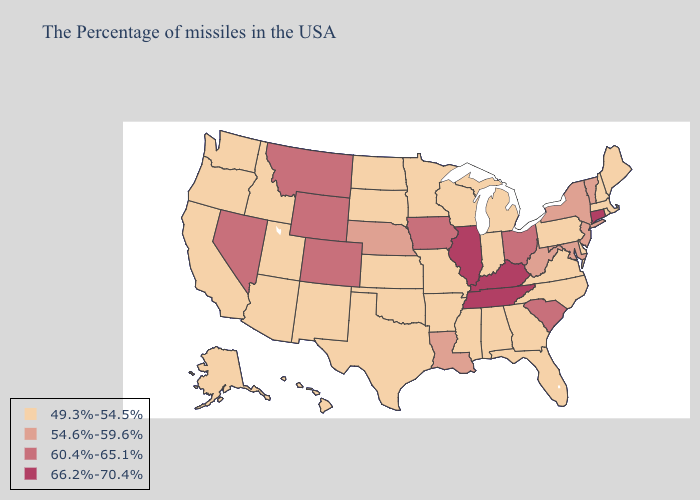How many symbols are there in the legend?
Give a very brief answer. 4. Name the states that have a value in the range 60.4%-65.1%?
Quick response, please. South Carolina, Ohio, Iowa, Wyoming, Colorado, Montana, Nevada. Does Alabama have the highest value in the South?
Short answer required. No. Does the first symbol in the legend represent the smallest category?
Quick response, please. Yes. What is the highest value in states that border Michigan?
Concise answer only. 60.4%-65.1%. Among the states that border North Carolina , does Georgia have the lowest value?
Keep it brief. Yes. What is the value of Massachusetts?
Be succinct. 49.3%-54.5%. Name the states that have a value in the range 66.2%-70.4%?
Be succinct. Connecticut, Kentucky, Tennessee, Illinois. Name the states that have a value in the range 54.6%-59.6%?
Keep it brief. Vermont, New York, New Jersey, Maryland, West Virginia, Louisiana, Nebraska. Among the states that border Missouri , does Kansas have the lowest value?
Quick response, please. Yes. Does Colorado have the same value as Pennsylvania?
Quick response, please. No. Name the states that have a value in the range 54.6%-59.6%?
Concise answer only. Vermont, New York, New Jersey, Maryland, West Virginia, Louisiana, Nebraska. Does Kentucky have the same value as Indiana?
Write a very short answer. No. Name the states that have a value in the range 60.4%-65.1%?
Give a very brief answer. South Carolina, Ohio, Iowa, Wyoming, Colorado, Montana, Nevada. Does the first symbol in the legend represent the smallest category?
Quick response, please. Yes. 